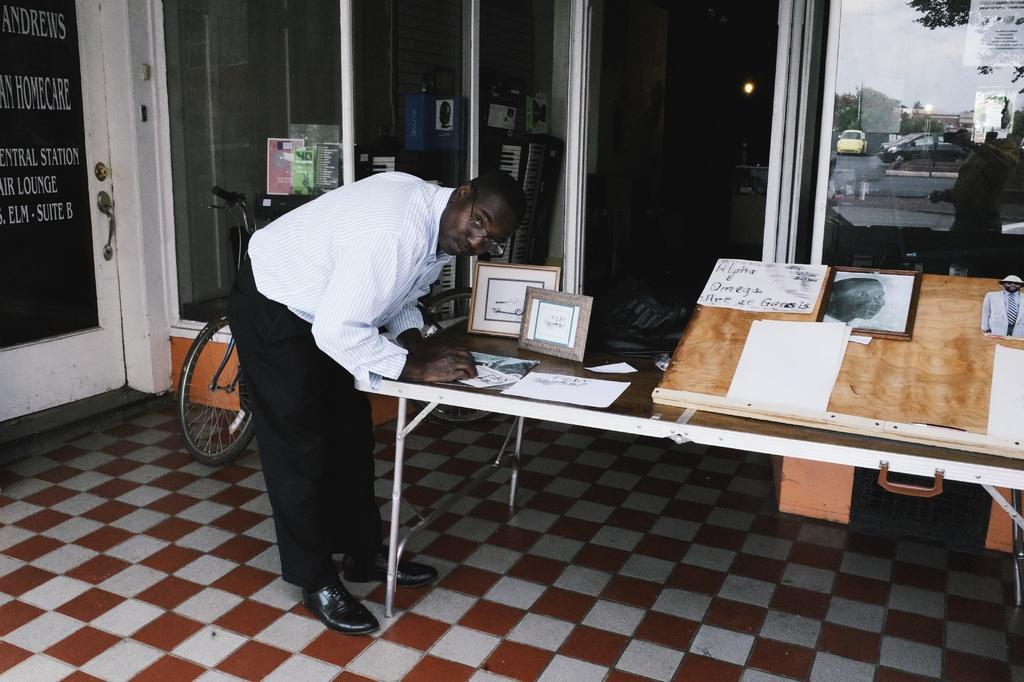Can you describe this image briefly? There is a person standing on the left side and he is looking at something. In the background we can see a bicycle, a glass door, a car and a tree which is on the right side. 